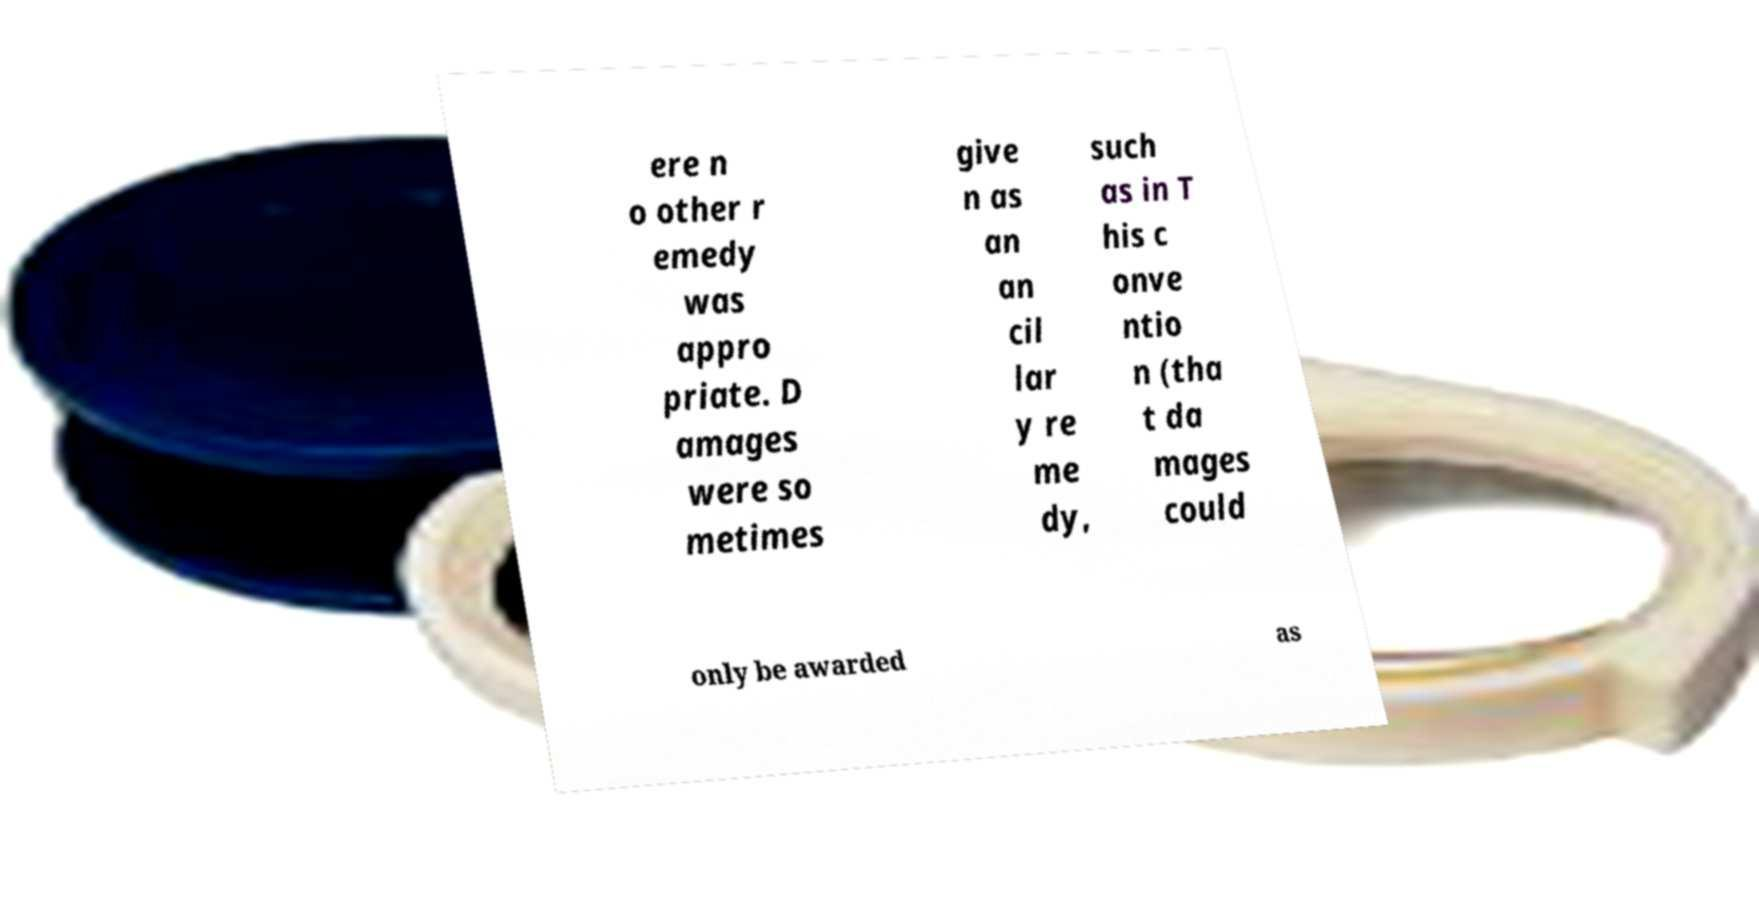For documentation purposes, I need the text within this image transcribed. Could you provide that? ere n o other r emedy was appro priate. D amages were so metimes give n as an an cil lar y re me dy, such as in T his c onve ntio n (tha t da mages could only be awarded as 